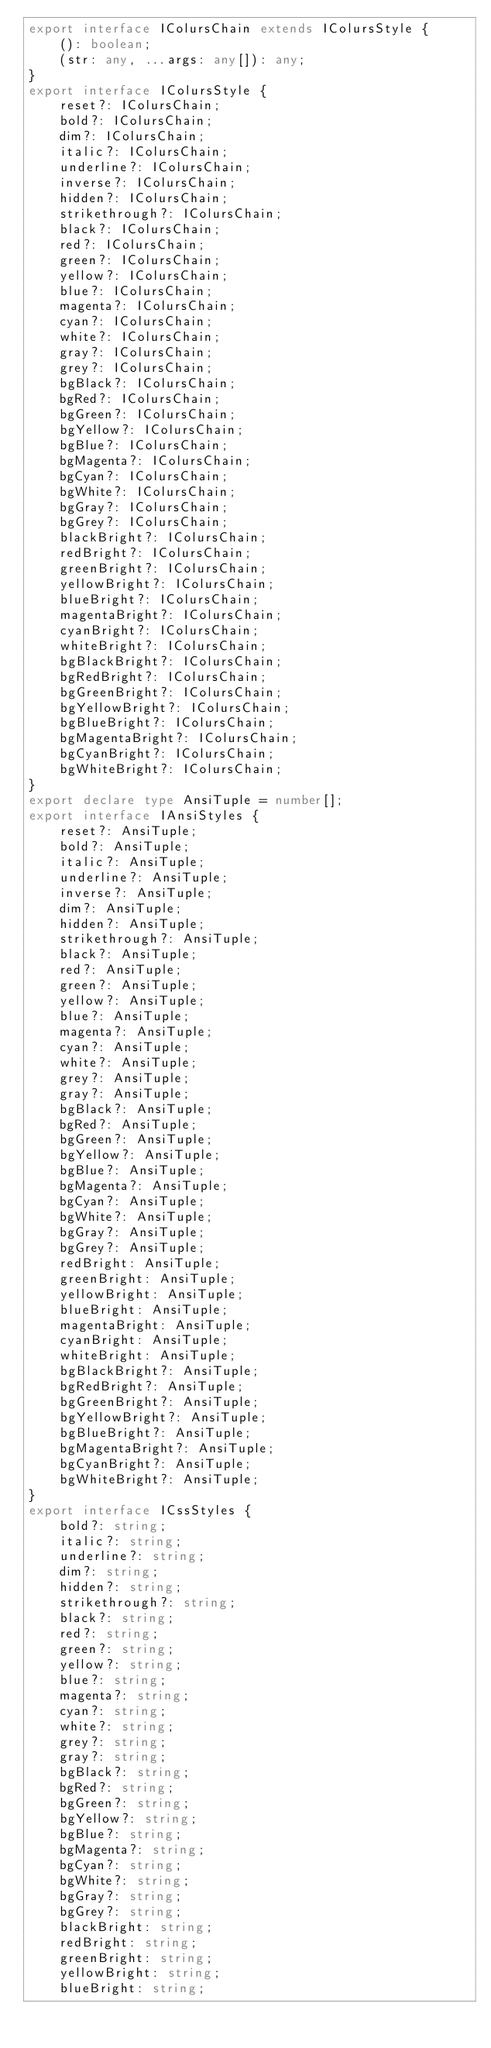Convert code to text. <code><loc_0><loc_0><loc_500><loc_500><_TypeScript_>export interface IColursChain extends IColursStyle {
    (): boolean;
    (str: any, ...args: any[]): any;
}
export interface IColursStyle {
    reset?: IColursChain;
    bold?: IColursChain;
    dim?: IColursChain;
    italic?: IColursChain;
    underline?: IColursChain;
    inverse?: IColursChain;
    hidden?: IColursChain;
    strikethrough?: IColursChain;
    black?: IColursChain;
    red?: IColursChain;
    green?: IColursChain;
    yellow?: IColursChain;
    blue?: IColursChain;
    magenta?: IColursChain;
    cyan?: IColursChain;
    white?: IColursChain;
    gray?: IColursChain;
    grey?: IColursChain;
    bgBlack?: IColursChain;
    bgRed?: IColursChain;
    bgGreen?: IColursChain;
    bgYellow?: IColursChain;
    bgBlue?: IColursChain;
    bgMagenta?: IColursChain;
    bgCyan?: IColursChain;
    bgWhite?: IColursChain;
    bgGray?: IColursChain;
    bgGrey?: IColursChain;
    blackBright?: IColursChain;
    redBright?: IColursChain;
    greenBright?: IColursChain;
    yellowBright?: IColursChain;
    blueBright?: IColursChain;
    magentaBright?: IColursChain;
    cyanBright?: IColursChain;
    whiteBright?: IColursChain;
    bgBlackBright?: IColursChain;
    bgRedBright?: IColursChain;
    bgGreenBright?: IColursChain;
    bgYellowBright?: IColursChain;
    bgBlueBright?: IColursChain;
    bgMagentaBright?: IColursChain;
    bgCyanBright?: IColursChain;
    bgWhiteBright?: IColursChain;
}
export declare type AnsiTuple = number[];
export interface IAnsiStyles {
    reset?: AnsiTuple;
    bold?: AnsiTuple;
    italic?: AnsiTuple;
    underline?: AnsiTuple;
    inverse?: AnsiTuple;
    dim?: AnsiTuple;
    hidden?: AnsiTuple;
    strikethrough?: AnsiTuple;
    black?: AnsiTuple;
    red?: AnsiTuple;
    green?: AnsiTuple;
    yellow?: AnsiTuple;
    blue?: AnsiTuple;
    magenta?: AnsiTuple;
    cyan?: AnsiTuple;
    white?: AnsiTuple;
    grey?: AnsiTuple;
    gray?: AnsiTuple;
    bgBlack?: AnsiTuple;
    bgRed?: AnsiTuple;
    bgGreen?: AnsiTuple;
    bgYellow?: AnsiTuple;
    bgBlue?: AnsiTuple;
    bgMagenta?: AnsiTuple;
    bgCyan?: AnsiTuple;
    bgWhite?: AnsiTuple;
    bgGray?: AnsiTuple;
    bgGrey?: AnsiTuple;
    redBright: AnsiTuple;
    greenBright: AnsiTuple;
    yellowBright: AnsiTuple;
    blueBright: AnsiTuple;
    magentaBright: AnsiTuple;
    cyanBright: AnsiTuple;
    whiteBright: AnsiTuple;
    bgBlackBright?: AnsiTuple;
    bgRedBright?: AnsiTuple;
    bgGreenBright?: AnsiTuple;
    bgYellowBright?: AnsiTuple;
    bgBlueBright?: AnsiTuple;
    bgMagentaBright?: AnsiTuple;
    bgCyanBright?: AnsiTuple;
    bgWhiteBright?: AnsiTuple;
}
export interface ICssStyles {
    bold?: string;
    italic?: string;
    underline?: string;
    dim?: string;
    hidden?: string;
    strikethrough?: string;
    black?: string;
    red?: string;
    green?: string;
    yellow?: string;
    blue?: string;
    magenta?: string;
    cyan?: string;
    white?: string;
    grey?: string;
    gray?: string;
    bgBlack?: string;
    bgRed?: string;
    bgGreen?: string;
    bgYellow?: string;
    bgBlue?: string;
    bgMagenta?: string;
    bgCyan?: string;
    bgWhite?: string;
    bgGray?: string;
    bgGrey?: string;
    blackBright: string;
    redBright: string;
    greenBright: string;
    yellowBright: string;
    blueBright: string;</code> 